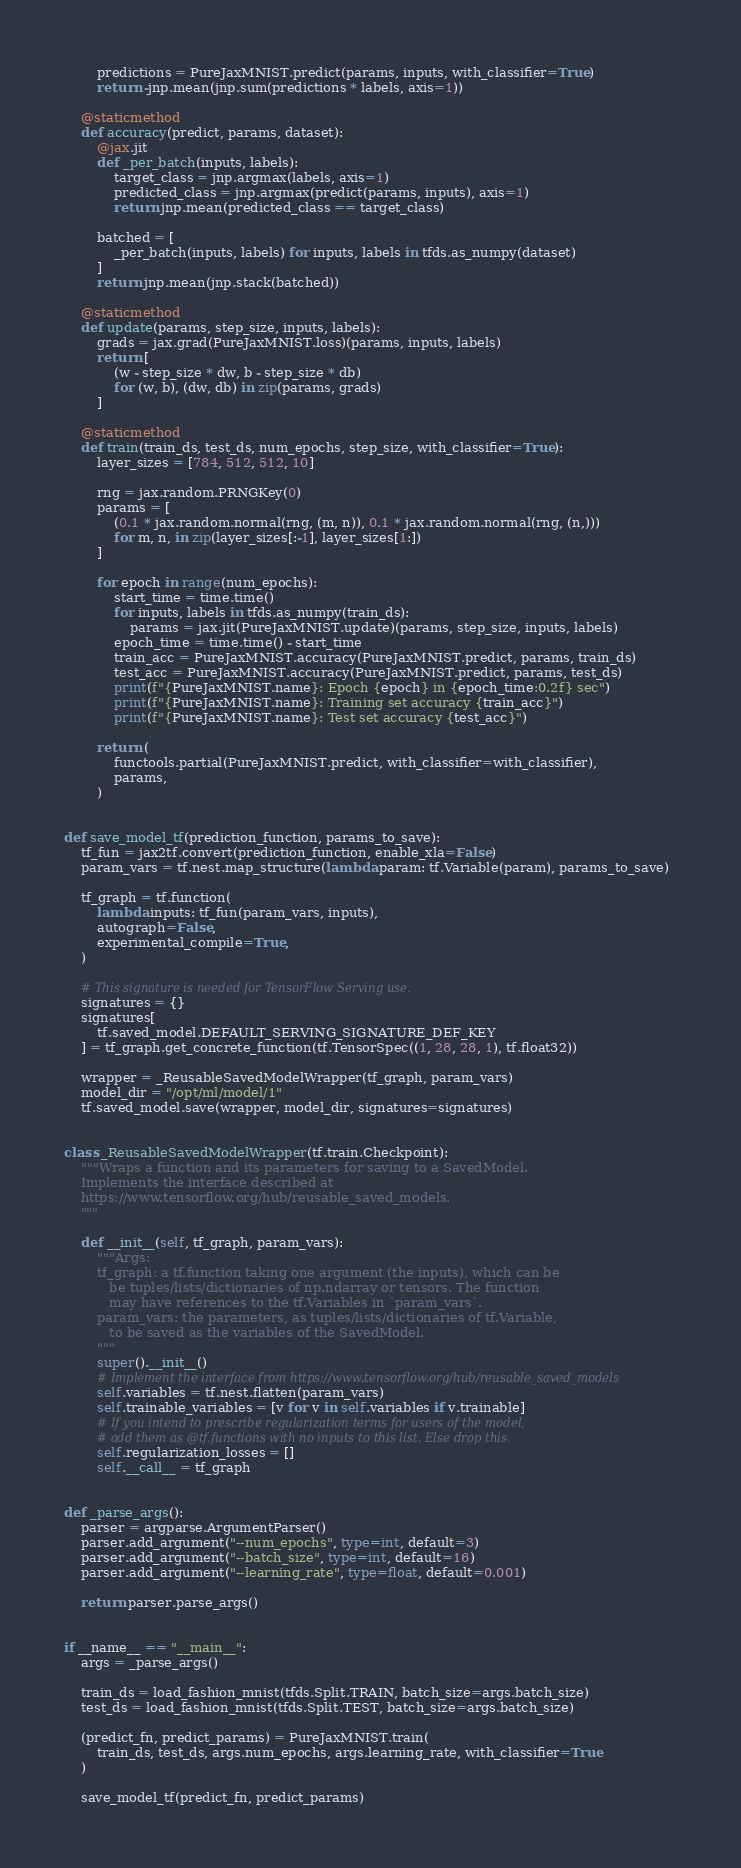<code> <loc_0><loc_0><loc_500><loc_500><_Python_>        predictions = PureJaxMNIST.predict(params, inputs, with_classifier=True)
        return -jnp.mean(jnp.sum(predictions * labels, axis=1))

    @staticmethod
    def accuracy(predict, params, dataset):
        @jax.jit
        def _per_batch(inputs, labels):
            target_class = jnp.argmax(labels, axis=1)
            predicted_class = jnp.argmax(predict(params, inputs), axis=1)
            return jnp.mean(predicted_class == target_class)

        batched = [
            _per_batch(inputs, labels) for inputs, labels in tfds.as_numpy(dataset)
        ]
        return jnp.mean(jnp.stack(batched))

    @staticmethod
    def update(params, step_size, inputs, labels):
        grads = jax.grad(PureJaxMNIST.loss)(params, inputs, labels)
        return [
            (w - step_size * dw, b - step_size * db)
            for (w, b), (dw, db) in zip(params, grads)
        ]

    @staticmethod
    def train(train_ds, test_ds, num_epochs, step_size, with_classifier=True):
        layer_sizes = [784, 512, 512, 10]

        rng = jax.random.PRNGKey(0)
        params = [
            (0.1 * jax.random.normal(rng, (m, n)), 0.1 * jax.random.normal(rng, (n,)))
            for m, n, in zip(layer_sizes[:-1], layer_sizes[1:])
        ]

        for epoch in range(num_epochs):
            start_time = time.time()
            for inputs, labels in tfds.as_numpy(train_ds):
                params = jax.jit(PureJaxMNIST.update)(params, step_size, inputs, labels)
            epoch_time = time.time() - start_time
            train_acc = PureJaxMNIST.accuracy(PureJaxMNIST.predict, params, train_ds)
            test_acc = PureJaxMNIST.accuracy(PureJaxMNIST.predict, params, test_ds)
            print(f"{PureJaxMNIST.name}: Epoch {epoch} in {epoch_time:0.2f} sec")
            print(f"{PureJaxMNIST.name}: Training set accuracy {train_acc}")
            print(f"{PureJaxMNIST.name}: Test set accuracy {test_acc}")

        return (
            functools.partial(PureJaxMNIST.predict, with_classifier=with_classifier),
            params,
        )


def save_model_tf(prediction_function, params_to_save):
    tf_fun = jax2tf.convert(prediction_function, enable_xla=False)
    param_vars = tf.nest.map_structure(lambda param: tf.Variable(param), params_to_save)

    tf_graph = tf.function(
        lambda inputs: tf_fun(param_vars, inputs),
        autograph=False,
        experimental_compile=True,
    )

    # This signature is needed for TensorFlow Serving use.
    signatures = {}
    signatures[
        tf.saved_model.DEFAULT_SERVING_SIGNATURE_DEF_KEY
    ] = tf_graph.get_concrete_function(tf.TensorSpec((1, 28, 28, 1), tf.float32))

    wrapper = _ReusableSavedModelWrapper(tf_graph, param_vars)
    model_dir = "/opt/ml/model/1"
    tf.saved_model.save(wrapper, model_dir, signatures=signatures)


class _ReusableSavedModelWrapper(tf.train.Checkpoint):
    """Wraps a function and its parameters for saving to a SavedModel.
    Implements the interface described at
    https://www.tensorflow.org/hub/reusable_saved_models.
    """

    def __init__(self, tf_graph, param_vars):
        """Args:
        tf_graph: a tf.function taking one argument (the inputs), which can be
           be tuples/lists/dictionaries of np.ndarray or tensors. The function
           may have references to the tf.Variables in `param_vars`.
        param_vars: the parameters, as tuples/lists/dictionaries of tf.Variable,
           to be saved as the variables of the SavedModel.
        """
        super().__init__()
        # Implement the interface from https://www.tensorflow.org/hub/reusable_saved_models
        self.variables = tf.nest.flatten(param_vars)
        self.trainable_variables = [v for v in self.variables if v.trainable]
        # If you intend to prescribe regularization terms for users of the model,
        # add them as @tf.functions with no inputs to this list. Else drop this.
        self.regularization_losses = []
        self.__call__ = tf_graph


def _parse_args():
    parser = argparse.ArgumentParser()
    parser.add_argument("--num_epochs", type=int, default=3)
    parser.add_argument("--batch_size", type=int, default=16)
    parser.add_argument("--learning_rate", type=float, default=0.001)

    return parser.parse_args()


if __name__ == "__main__":
    args = _parse_args()

    train_ds = load_fashion_mnist(tfds.Split.TRAIN, batch_size=args.batch_size)
    test_ds = load_fashion_mnist(tfds.Split.TEST, batch_size=args.batch_size)

    (predict_fn, predict_params) = PureJaxMNIST.train(
        train_ds, test_ds, args.num_epochs, args.learning_rate, with_classifier=True
    )

    save_model_tf(predict_fn, predict_params)
</code> 